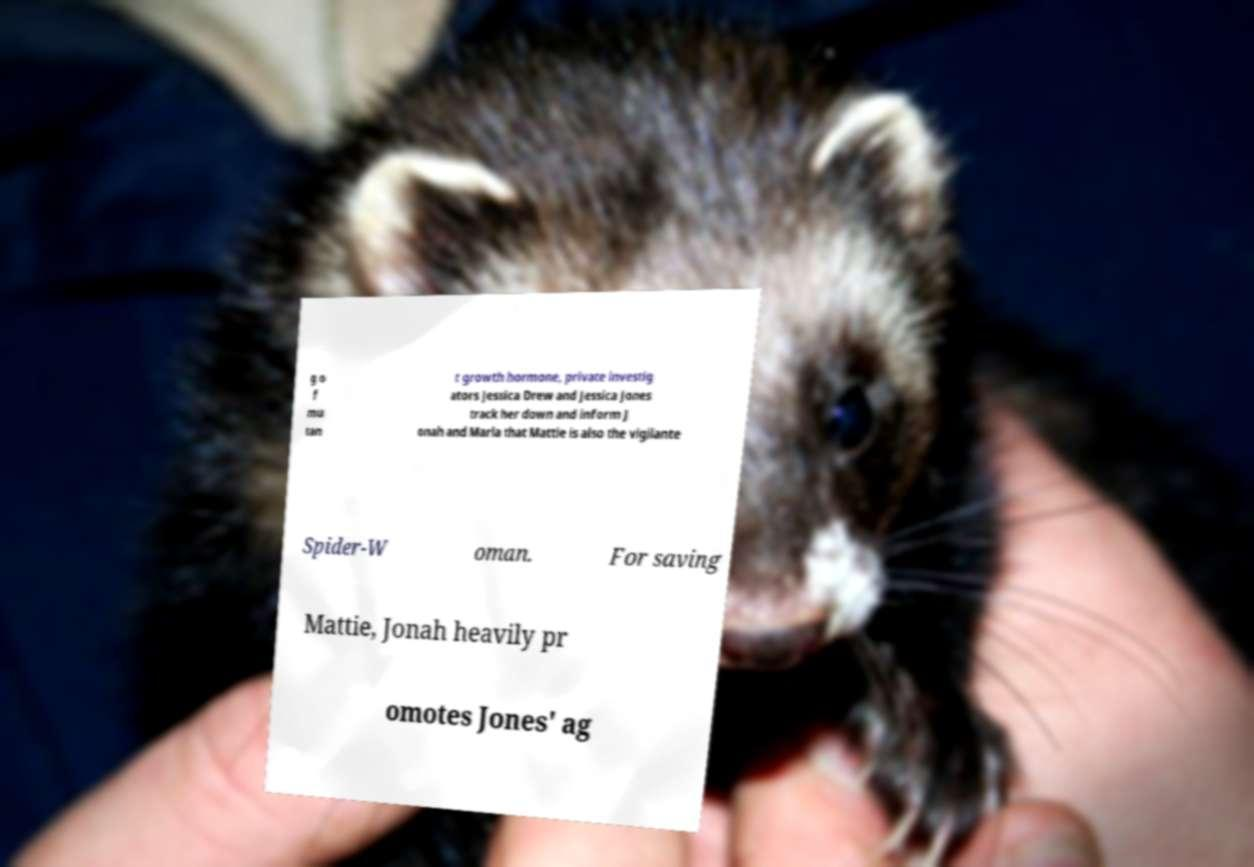Can you read and provide the text displayed in the image?This photo seems to have some interesting text. Can you extract and type it out for me? g o f mu tan t growth hormone, private investig ators Jessica Drew and Jessica Jones track her down and inform J onah and Marla that Mattie is also the vigilante Spider-W oman. For saving Mattie, Jonah heavily pr omotes Jones' ag 